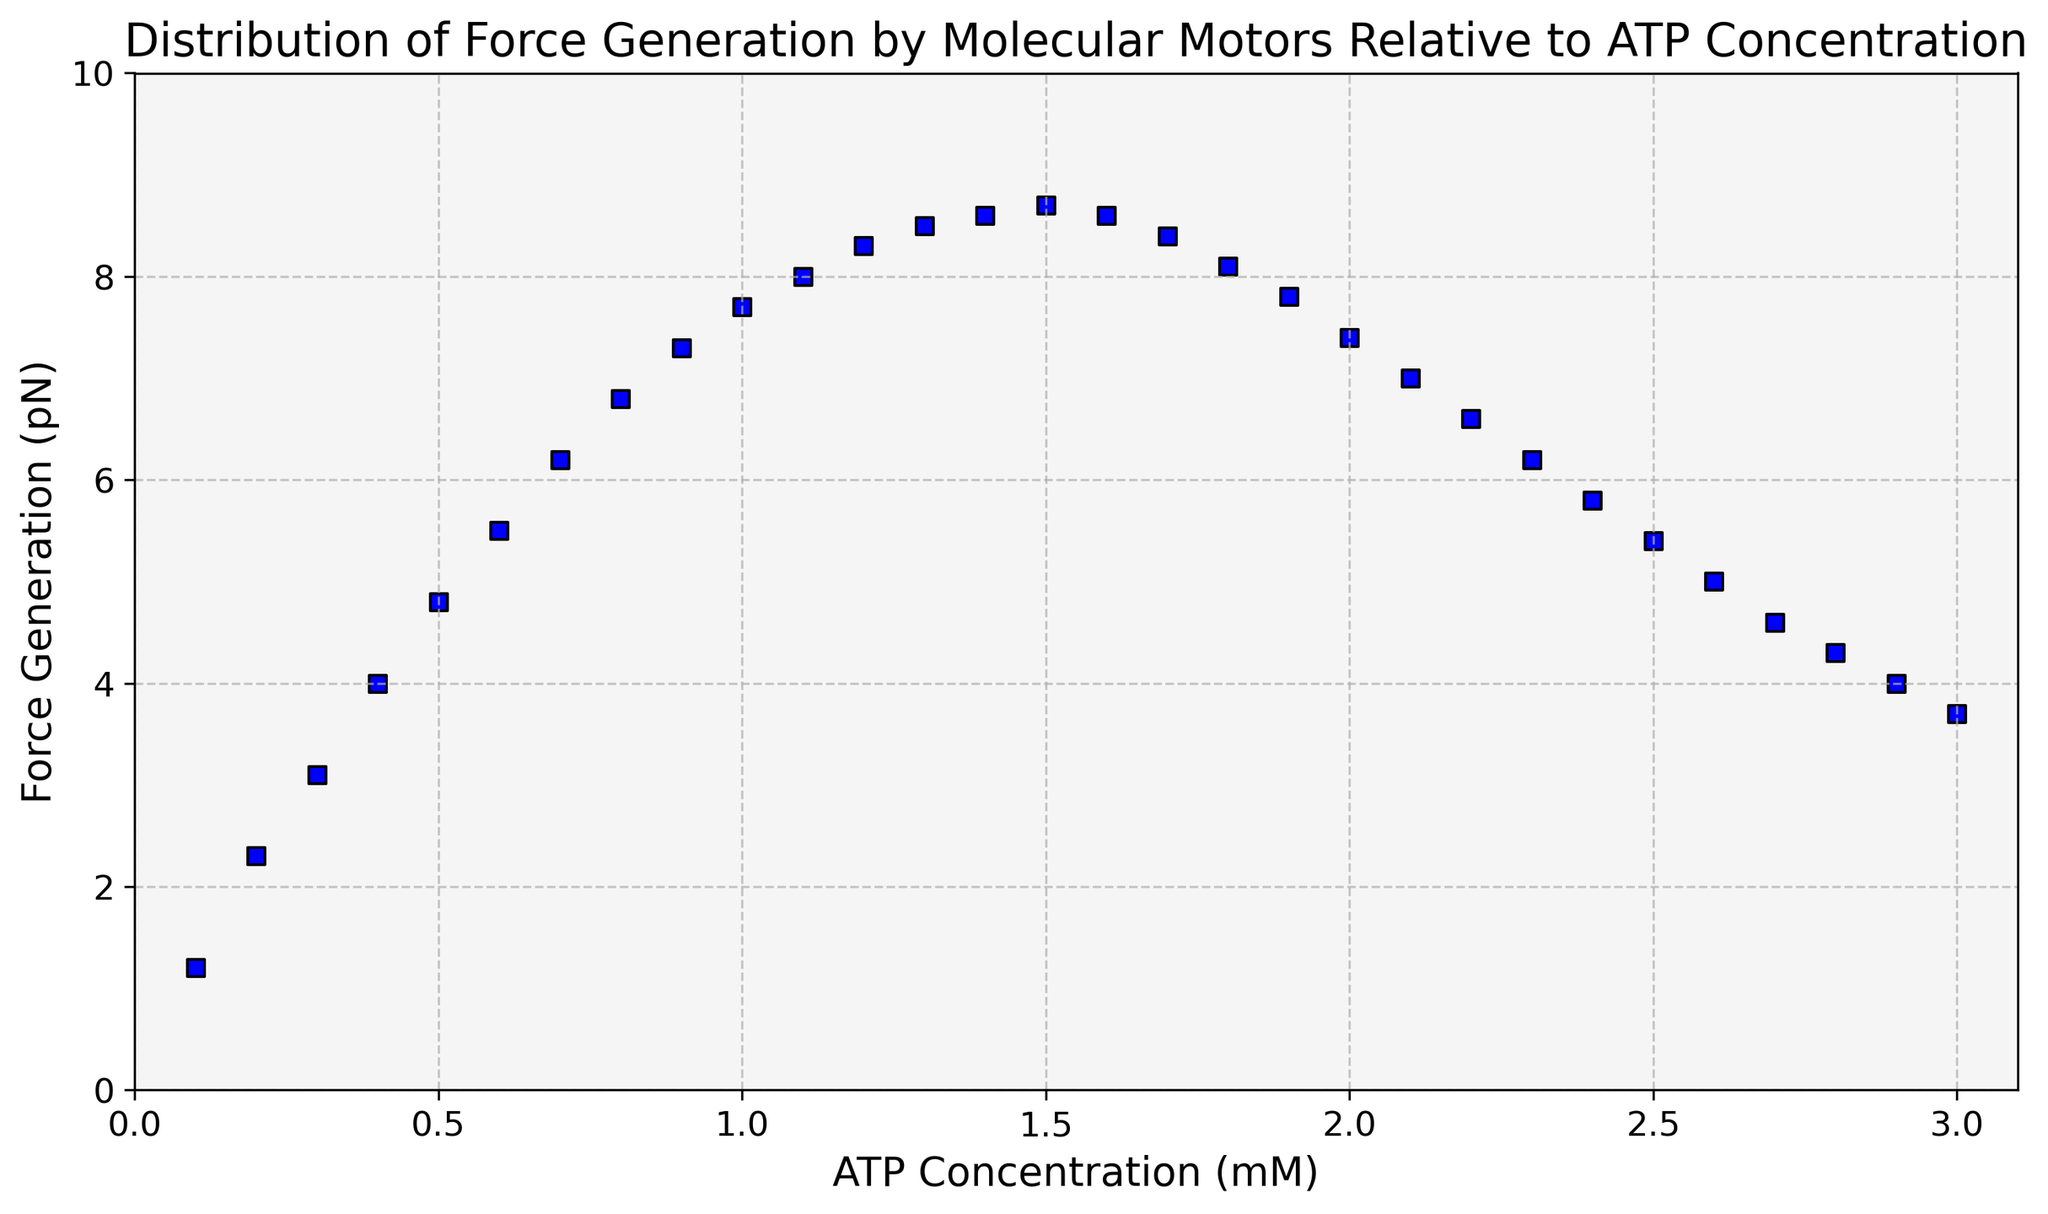What is the highest force generated by molecular motors? The highest force generated can be visually identified as the maximum y-axis value reached by the scatter points. In this plot, the highest y-value is close to 8.7 pN.
Answer: 8.7 pN At what ATP concentration does the force generation peak? The peak force generation occurs where the y-values (Force) reach their maximum. From the plot, this is around an ATP concentration of 1.5 mM.
Answer: 1.5 mM How does force generation change as ATP concentration increases from 0.1 mM to 1.5 mM? You need to observe the trend of the scatter points as the x-axis (ATP concentration) increases from 0.1 mM to 1.5 mM. The force generation increases continuously from 1.2 pN to 8.7 pN.
Answer: Increases What happens to force generation after the ATP concentration exceeds 1.5 mM? After reaching the peak at 1.5 mM, observe the trend of the y-values (Force) as the x-value (ATP concentration) continues to increase. Force generation decreases from 8.7 pN to around 3.7 pN at 3.0 mM ATP concentration.
Answer: Decreases At which ATP concentration does the force generation start to decline? To answer this, look for the highest value on the y-axis (peak force) and determine the corresponding x-axis value. The force generation starts to decline shortly after reaching 1.5 mM ATP concentration.
Answer: Shortly after 1.5 mM What is the force generated at an ATP concentration of 1.0 mM? Find the scatter point that aligns with 1.0 mM on the x-axis and then read off the corresponding y-axis value. The force generated here is around 7.7 pN.
Answer: 7.7 pN Compare the force generated at 0.5 mM and 2.5 mM ATP concentrations. Identify the scatter points for 0.5 mM and 2.5 mM on the x-axis and compare their y-values. At 0.5 mM, the force is around 4.8 pN, and at 2.5 mM, it is about 5.4 pN.
Answer: Higher at 2.5 mM What is the overall trend of force generation as ATP concentration changes from 0.1 mM to 3.0 mM? Observe the overall pattern of the scatter points from the lowest to the highest x-axis value. Initially, force generation increases reaching a peak, then gradually decreases after the peak.
Answer: Increase then decrease What is the average force generation between 0.2 mM and 1.0 mM ATP concentrations? Find the scatter points corresponding to the ATP concentrations between 0.2 mM and 1.0 mM, sum their forces and divide by the number of points. Forces are 2.3, 3.1, 4.0, 4.8, 5.5, 6.2, 6.8, 7.3, 7.7 pN. The average is (2.3+3.1+4.0+4.8+5.5+6.2+6.8+7.3+7.7) / 9 = 5.41 pN.
Answer: 5.41 pN What is the range of force generated at ATP concentrations up to 1.5 mM? Find the minimum and maximum y-values between 0 and 1.5 mM inclusive. Minimum is 1.2 pN and the maximum is 8.7 pN. Therefore, the range is 8.7 pN - 1.2 pN = 7.5 pN.
Answer: 7.5 pN 